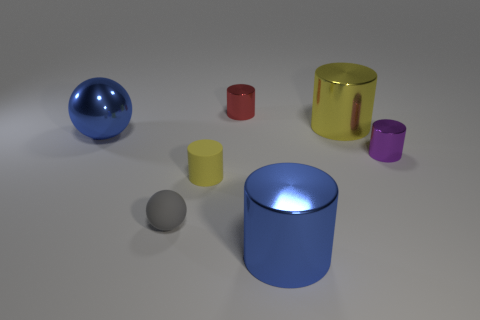What is the shape of the shiny thing to the left of the yellow matte cylinder?
Provide a short and direct response. Sphere. There is a purple cylinder; does it have the same size as the gray rubber thing that is to the left of the small yellow object?
Offer a terse response. Yes. Are there any large things made of the same material as the large sphere?
Provide a short and direct response. Yes. How many balls are big brown metallic objects or small gray objects?
Your response must be concise. 1. Is there a big yellow thing that is behind the large blue thing in front of the tiny yellow rubber object?
Your answer should be compact. Yes. Are there fewer gray spheres than green metallic balls?
Provide a short and direct response. No. How many green rubber things have the same shape as the yellow shiny object?
Your answer should be very brief. 0. How many gray things are matte cylinders or shiny objects?
Offer a very short reply. 0. What is the size of the blue object that is left of the big blue shiny object right of the red metallic object?
Offer a very short reply. Large. There is a purple thing that is the same shape as the big yellow object; what is it made of?
Your answer should be very brief. Metal. 